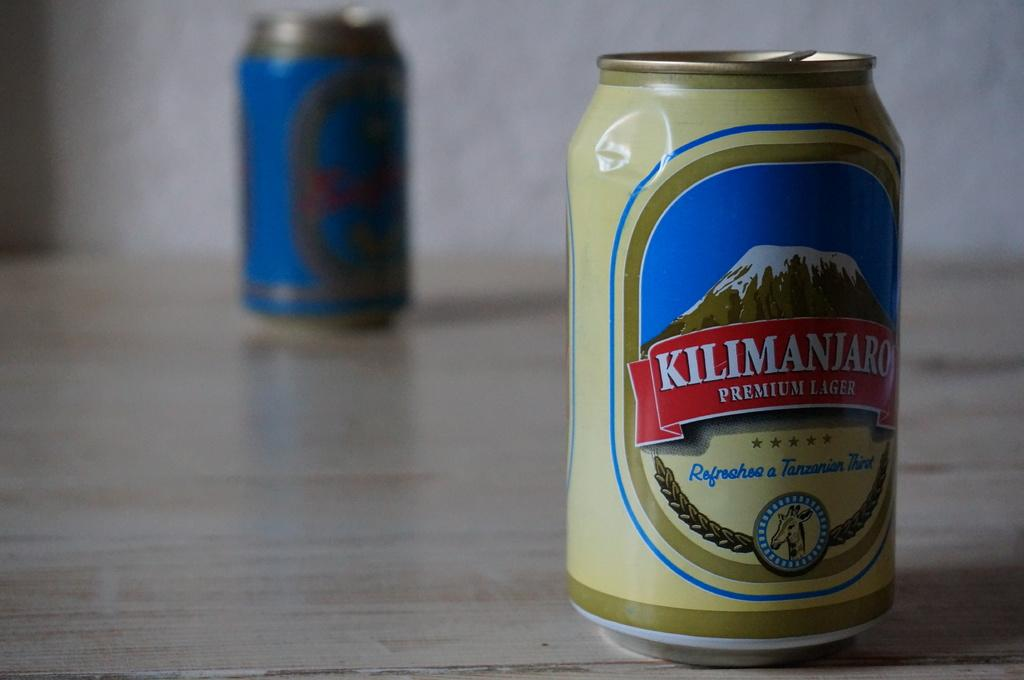<image>
Create a compact narrative representing the image presented. A brown can of beer that says Kilimanjaro Premium Lager is on a wooden table. 